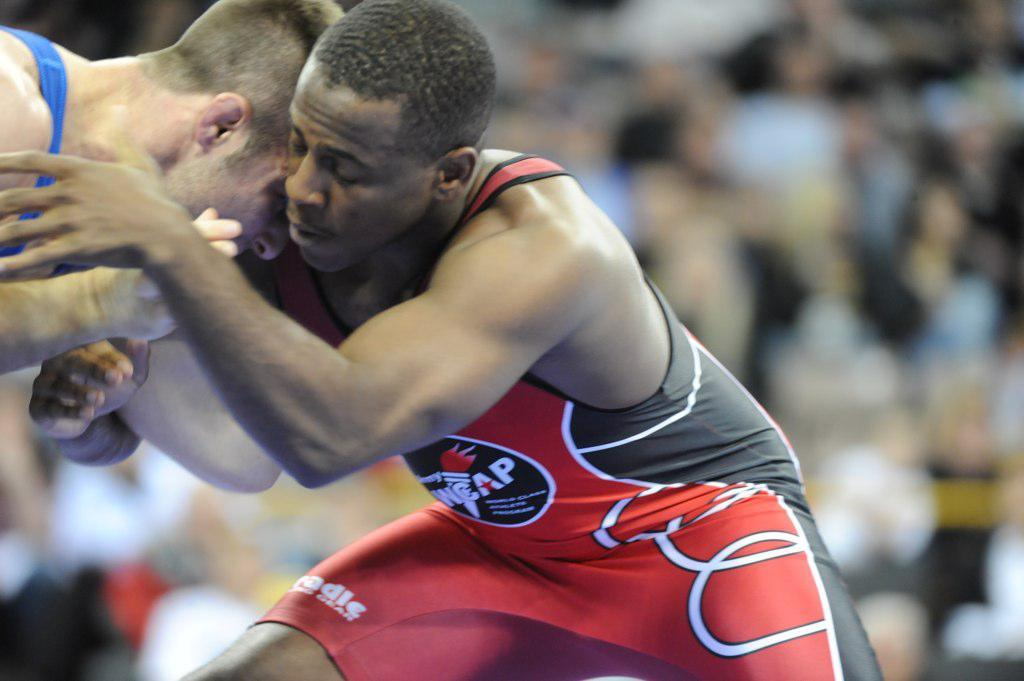What is happening between the two individuals in the image? The two individuals in the image are wrestlers fighting with each other. What can be observed about the background of the image? The background of the image is blurred. Are there any other people visible in the image? Yes, there are people (audience) sitting in the background. What type of caption is written on the canvas in the image? There is no canvas or caption present in the image; it features two wrestlers fighting with each other and an audience in the background. 